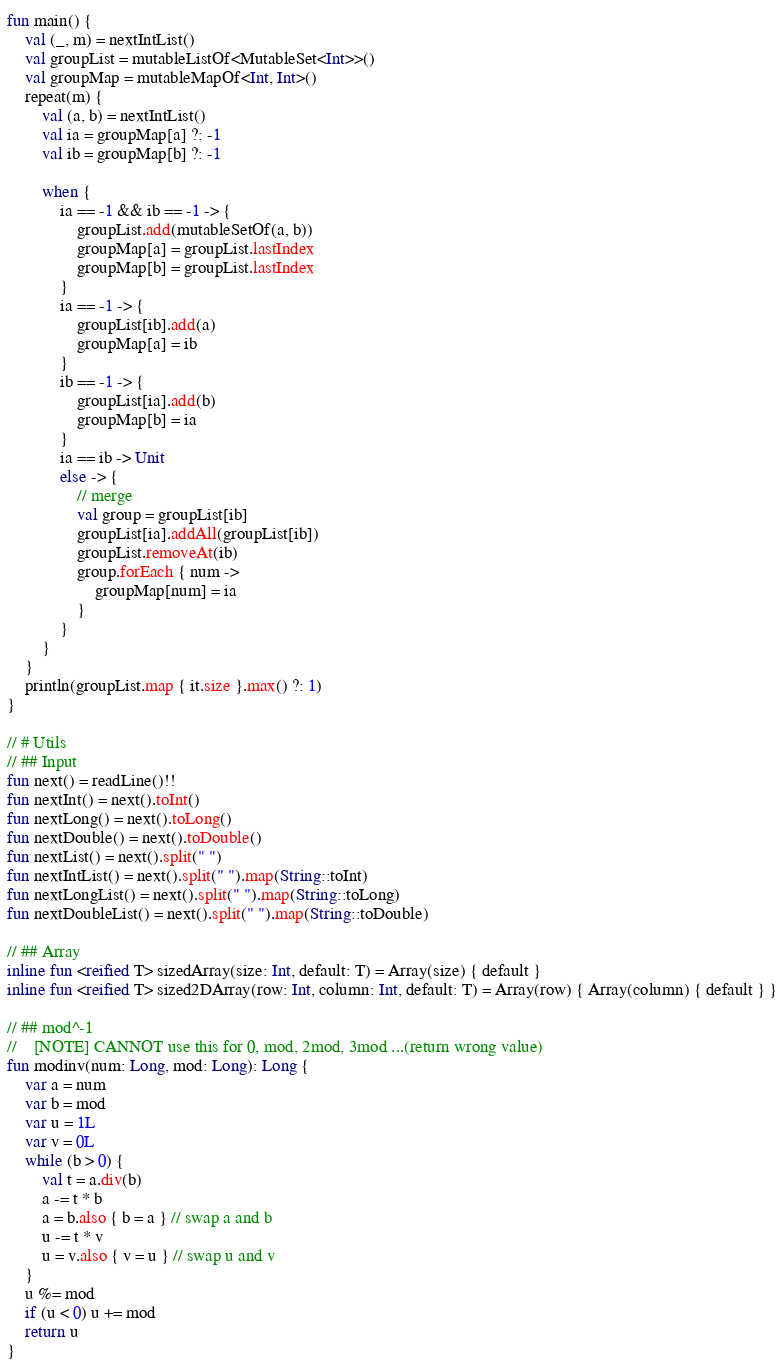Convert code to text. <code><loc_0><loc_0><loc_500><loc_500><_Kotlin_>fun main() {
    val (_, m) = nextIntList()
    val groupList = mutableListOf<MutableSet<Int>>()
    val groupMap = mutableMapOf<Int, Int>()
    repeat(m) {
        val (a, b) = nextIntList()
        val ia = groupMap[a] ?: -1
        val ib = groupMap[b] ?: -1

        when {
            ia == -1 && ib == -1 -> {
                groupList.add(mutableSetOf(a, b))
                groupMap[a] = groupList.lastIndex
                groupMap[b] = groupList.lastIndex
            }
            ia == -1 -> {
                groupList[ib].add(a)
                groupMap[a] = ib
            }
            ib == -1 -> {
                groupList[ia].add(b)
                groupMap[b] = ia
            }
            ia == ib -> Unit
            else -> {
                // merge
                val group = groupList[ib]
                groupList[ia].addAll(groupList[ib])
                groupList.removeAt(ib)
                group.forEach { num ->
                    groupMap[num] = ia
                }
            }
        }
    }
    println(groupList.map { it.size }.max() ?: 1)
}

// # Utils
// ## Input
fun next() = readLine()!!
fun nextInt() = next().toInt()
fun nextLong() = next().toLong()
fun nextDouble() = next().toDouble()
fun nextList() = next().split(" ")
fun nextIntList() = next().split(" ").map(String::toInt)
fun nextLongList() = next().split(" ").map(String::toLong)
fun nextDoubleList() = next().split(" ").map(String::toDouble)

// ## Array
inline fun <reified T> sizedArray(size: Int, default: T) = Array(size) { default }
inline fun <reified T> sized2DArray(row: Int, column: Int, default: T) = Array(row) { Array(column) { default } }

// ## mod^-1
//    [NOTE] CANNOT use this for 0, mod, 2mod, 3mod ...(return wrong value)
fun modinv(num: Long, mod: Long): Long {
    var a = num
    var b = mod
    var u = 1L
    var v = 0L
    while (b > 0) {
        val t = a.div(b)
        a -= t * b
        a = b.also { b = a } // swap a and b
        u -= t * v
        u = v.also { v = u } // swap u and v
    }
    u %= mod
    if (u < 0) u += mod
    return u
}</code> 